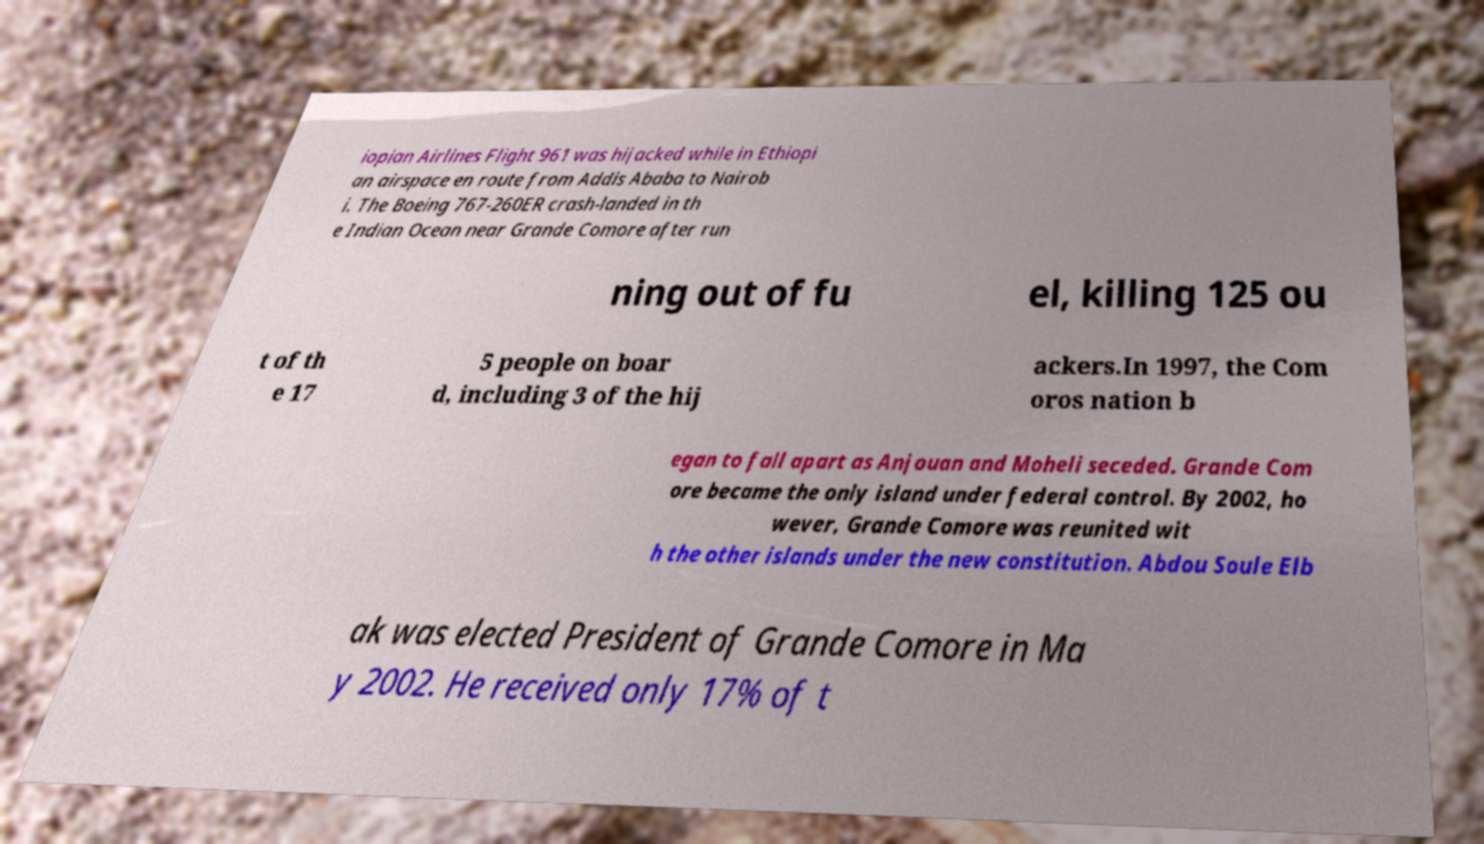Could you extract and type out the text from this image? iopian Airlines Flight 961 was hijacked while in Ethiopi an airspace en route from Addis Ababa to Nairob i. The Boeing 767-260ER crash-landed in th e Indian Ocean near Grande Comore after run ning out of fu el, killing 125 ou t of th e 17 5 people on boar d, including 3 of the hij ackers.In 1997, the Com oros nation b egan to fall apart as Anjouan and Moheli seceded. Grande Com ore became the only island under federal control. By 2002, ho wever, Grande Comore was reunited wit h the other islands under the new constitution. Abdou Soule Elb ak was elected President of Grande Comore in Ma y 2002. He received only 17% of t 